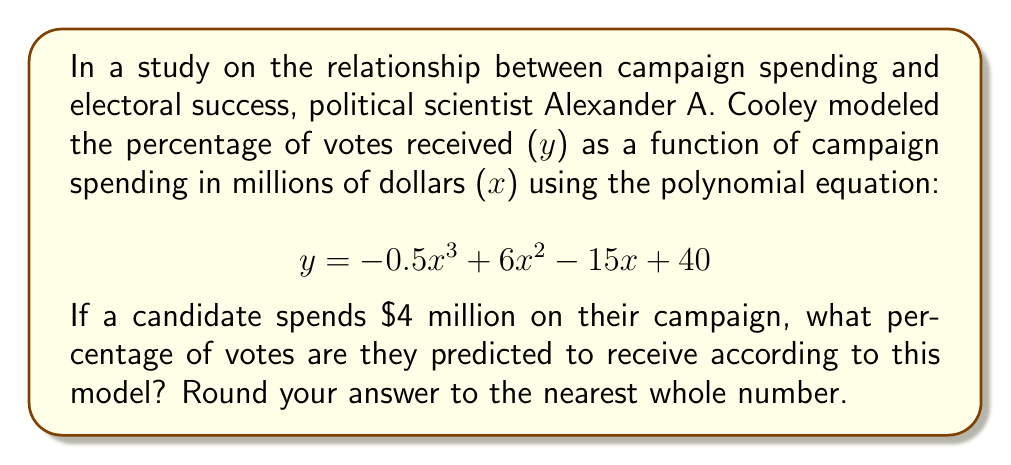Can you answer this question? To solve this problem, we need to follow these steps:

1) We have the polynomial equation:
   $$ y = -0.5x^3 + 6x^2 - 15x + 40 $$

2) We need to substitute x = 4 (since the candidate spends $4 million) into this equation:
   $$ y = -0.5(4)^3 + 6(4)^2 - 15(4) + 40 $$

3) Let's calculate each term:
   - $-0.5(4)^3 = -0.5(64) = -32$
   - $6(4)^2 = 6(16) = 96$
   - $-15(4) = -60$
   - The constant term is 40

4) Now, let's add these terms:
   $$ y = -32 + 96 - 60 + 40 = 44 $$

5) Therefore, according to this model, a candidate who spends $4 million on their campaign is predicted to receive 44% of the votes.

6) The question asks to round to the nearest whole number, but 44 is already a whole number, so no rounding is necessary.
Answer: 44% 